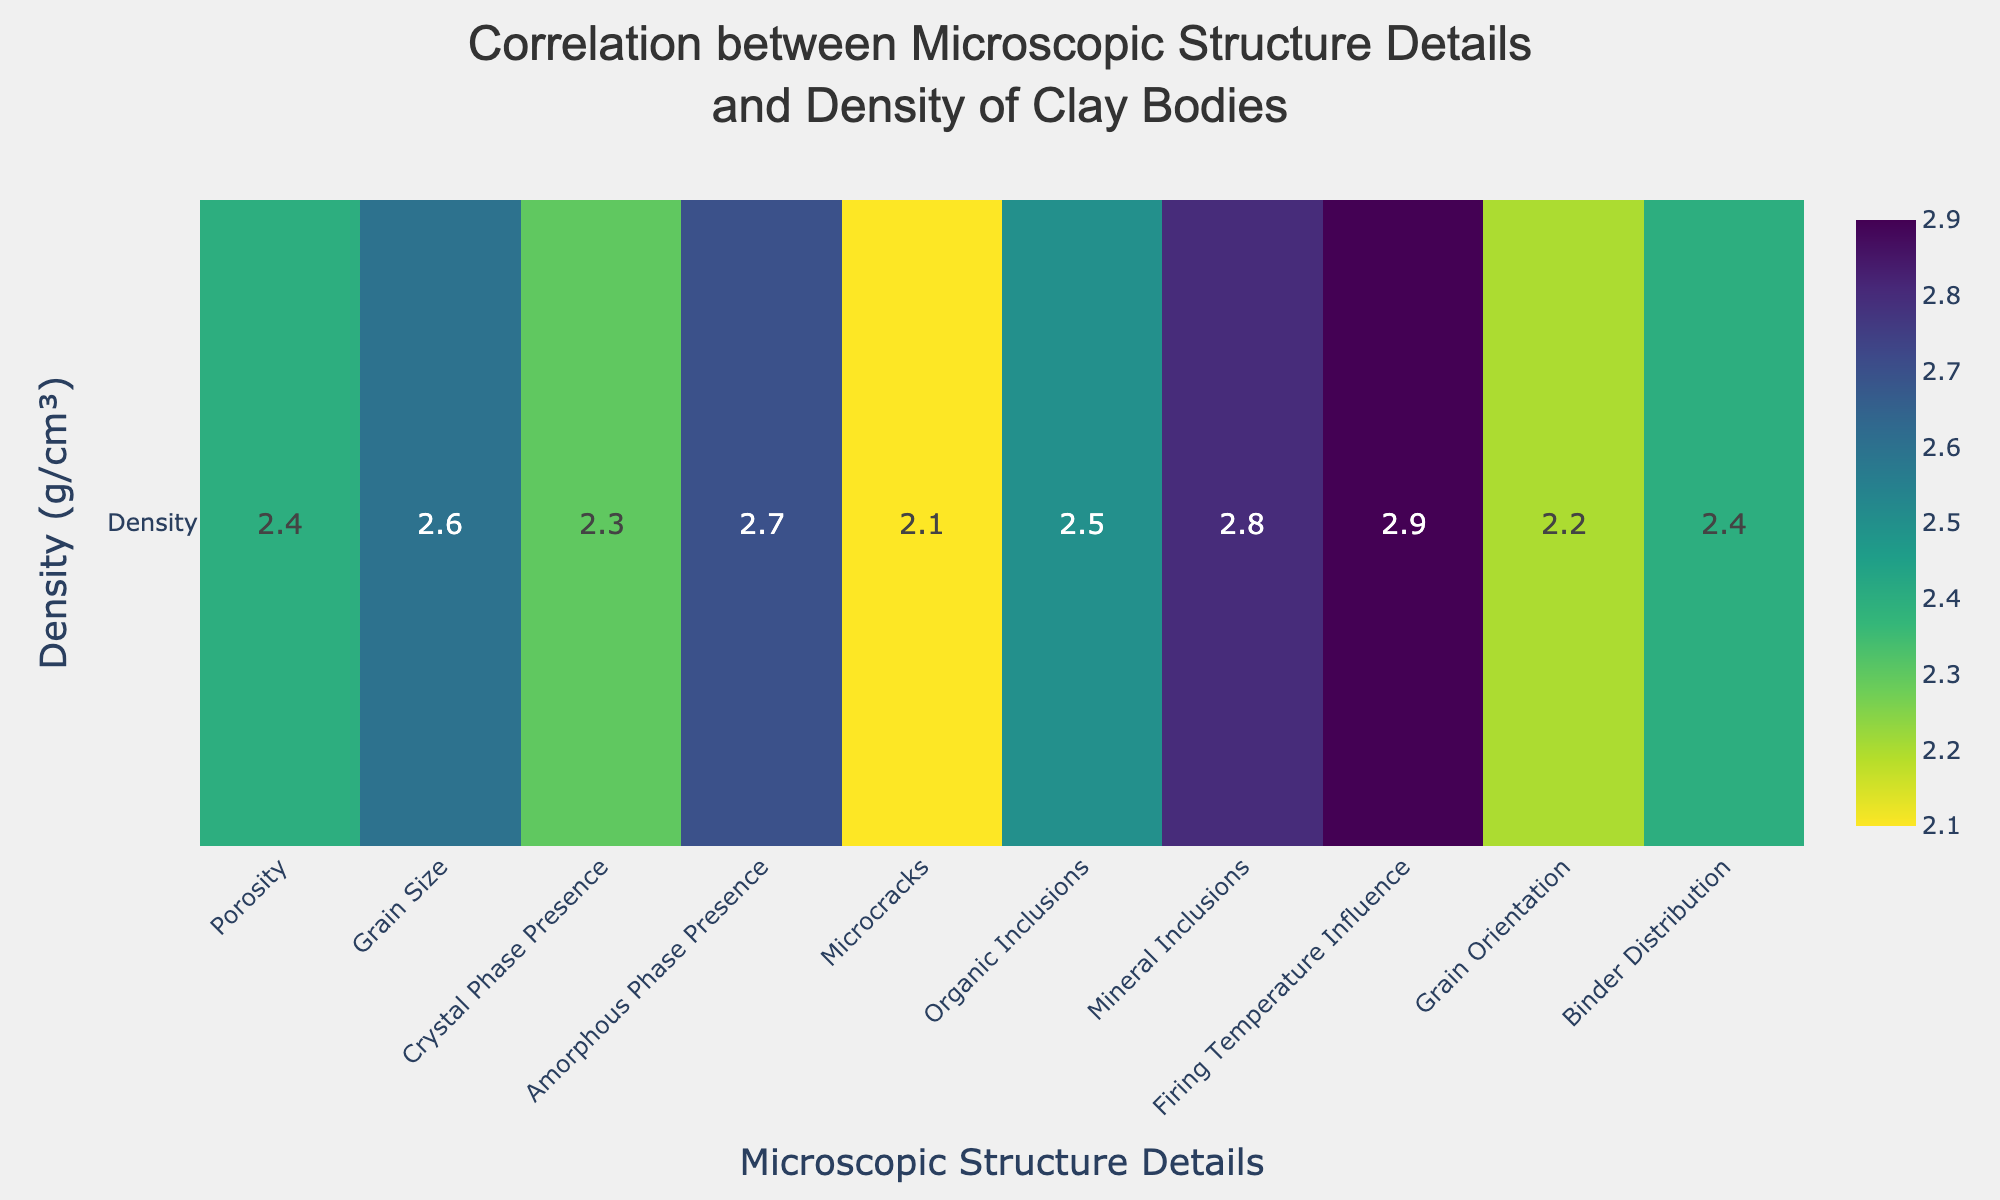What is the title of the heatmap? The title is located at the top of the heatmap, indicating the main purpose of the chart. It reads: "Correlation between Microscopic Structure Details and Density of Clay Bodies."
Answer: Correlation between Microscopic Structure Details and Density of Clay Bodies Which microscopic structure detail has the highest density value? The highest density value can be determined by looking at the color intensity in the heatmap and the corresponding value. "Firing Temperature Influence" has the highest value at 2.9.
Answer: Firing Temperature Influence What is the density value for Grain Orientation? The density values are displayed directly on the heatmap tiles. For "Grain Orientation," the density value is 2.2.
Answer: 2.2 How does the density of Crystal Phase Presence compare to Amorphous Phase Presence? Comparing the values directly from the heatmap, the density for "Crystal Phase Presence" is 2.3, while for "Amorphous Phase Presence," it is 2.7. Thus, the density for Amorphous Phase Presence is higher.
Answer: Amorphous Phase Presence is higher What is the average density value across all microscopic structure details? To calculate the average density, sum all density values and divide by the number of details. The sum of densities is 25.9 (2.4+2.6+2.3+2.7+2.1+2.5+2.8+2.9+2.2+2.4), divided by 10 details, equals 2.59.
Answer: 2.59 Which microscopic structure detail has a density value equal to 2.8? By checking the heatmap, "Mineral Inclusions" has the density value of 2.8.
Answer: Mineral Inclusions What is the difference in density values between Porosity and Microcracks? The density value for "Porosity" is 2.4, and for "Microcracks," it is 2.1. The difference is 2.4 - 2.1 = 0.3.
Answer: 0.3 Are there any microscopic structure details with density values less than 2.2? Checking the heatmap for any values less than 2.2, "Microcracks" (2.1) and "Grain Orientation" (2.2) fulfill this condition.
Answer: Microcracks Which detail has a density value closest to the average density value? The average density is 2.59. Comparing the values, "Binder Distribution" and "Porosity," both with 2.4, and "Grain Size," with 2.6, are closest. Between these three details, "Grain Size" at 2.6 is the closest to 2.59.
Answer: Grain Size How many microscopic structure details have a density value greater than 2.5? By counting the values over 2.5 from the heatmap, there are five: "Grain Size," "Amorphous Phase Presence," "Organic Inclusions," "Mineral Inclusions," and "Firing Temperature Influence."
Answer: 5 